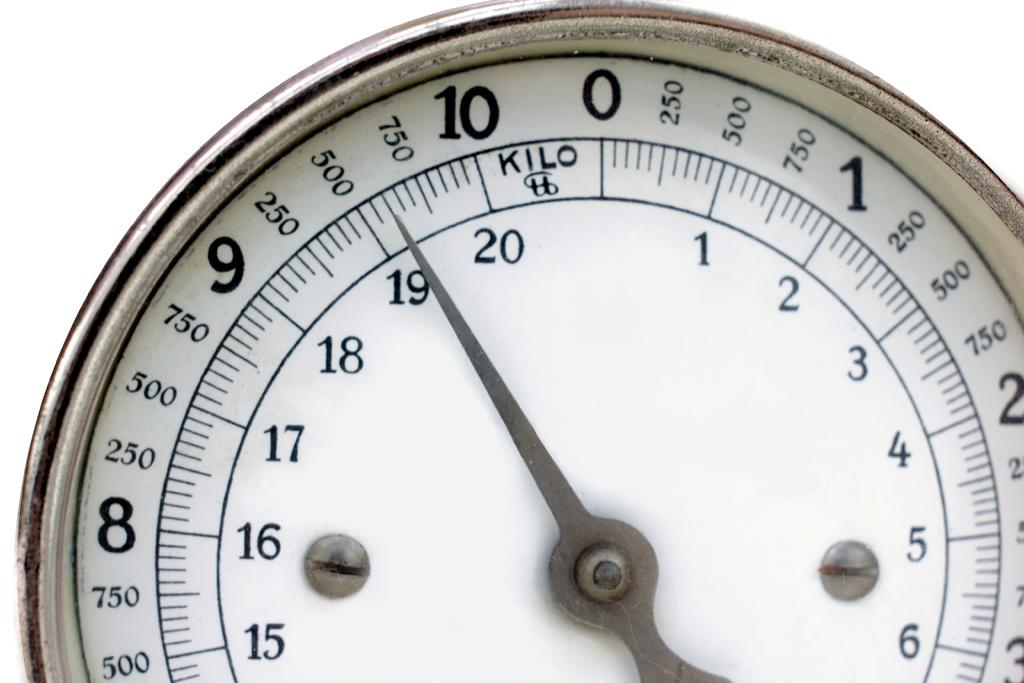<image>
Relay a brief, clear account of the picture shown. A watch that measures kilo up to seven hundred and fifty. 